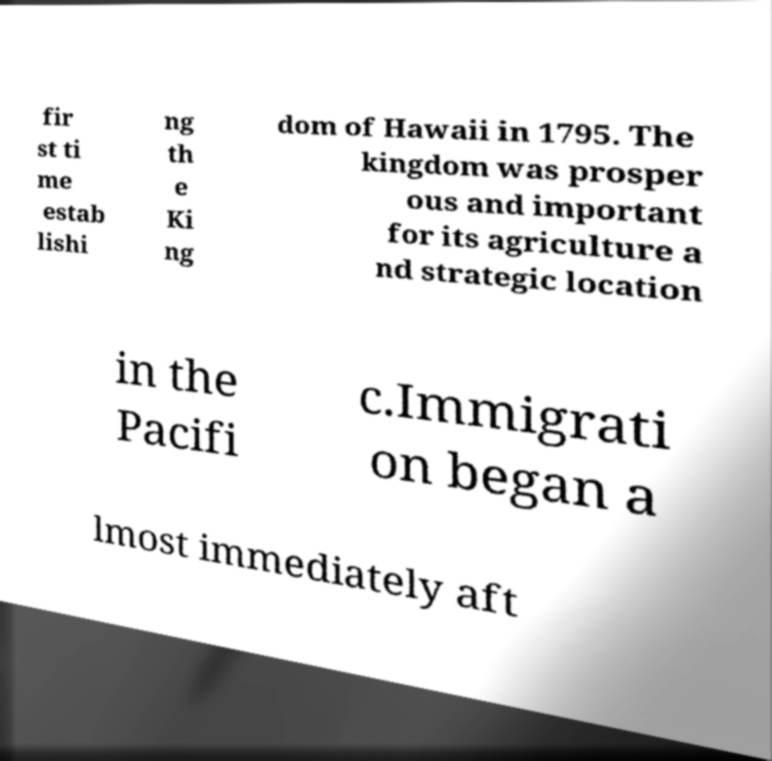Please identify and transcribe the text found in this image. fir st ti me estab lishi ng th e Ki ng dom of Hawaii in 1795. The kingdom was prosper ous and important for its agriculture a nd strategic location in the Pacifi c.Immigrati on began a lmost immediately aft 